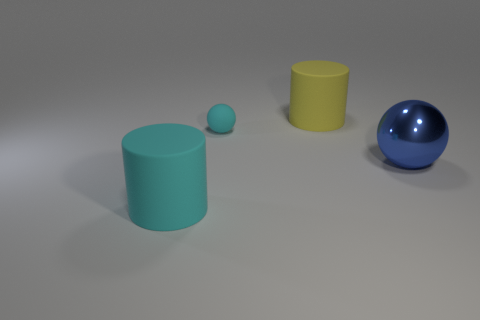There is a cyan matte thing behind the cyan rubber cylinder; what number of large yellow objects are behind it?
Your answer should be very brief. 1. There is a big blue thing that is right of the big cylinder that is in front of the big yellow rubber cylinder; is there a large blue thing that is to the left of it?
Your answer should be very brief. No. There is another large thing that is the same shape as the big cyan matte object; what is its material?
Your answer should be compact. Rubber. Are there any other things that are made of the same material as the yellow thing?
Offer a terse response. Yes. Are the big yellow cylinder and the large blue sphere that is behind the big cyan rubber cylinder made of the same material?
Offer a terse response. No. The large thing left of the yellow object behind the big metallic thing is what shape?
Your answer should be very brief. Cylinder. How many tiny things are either yellow things or metallic spheres?
Your answer should be compact. 0. What number of matte objects are the same shape as the metallic object?
Offer a very short reply. 1. Does the big cyan rubber object have the same shape as the big rubber object that is behind the blue metal thing?
Your answer should be compact. Yes. There is a yellow object; what number of matte balls are right of it?
Your answer should be very brief. 0. 